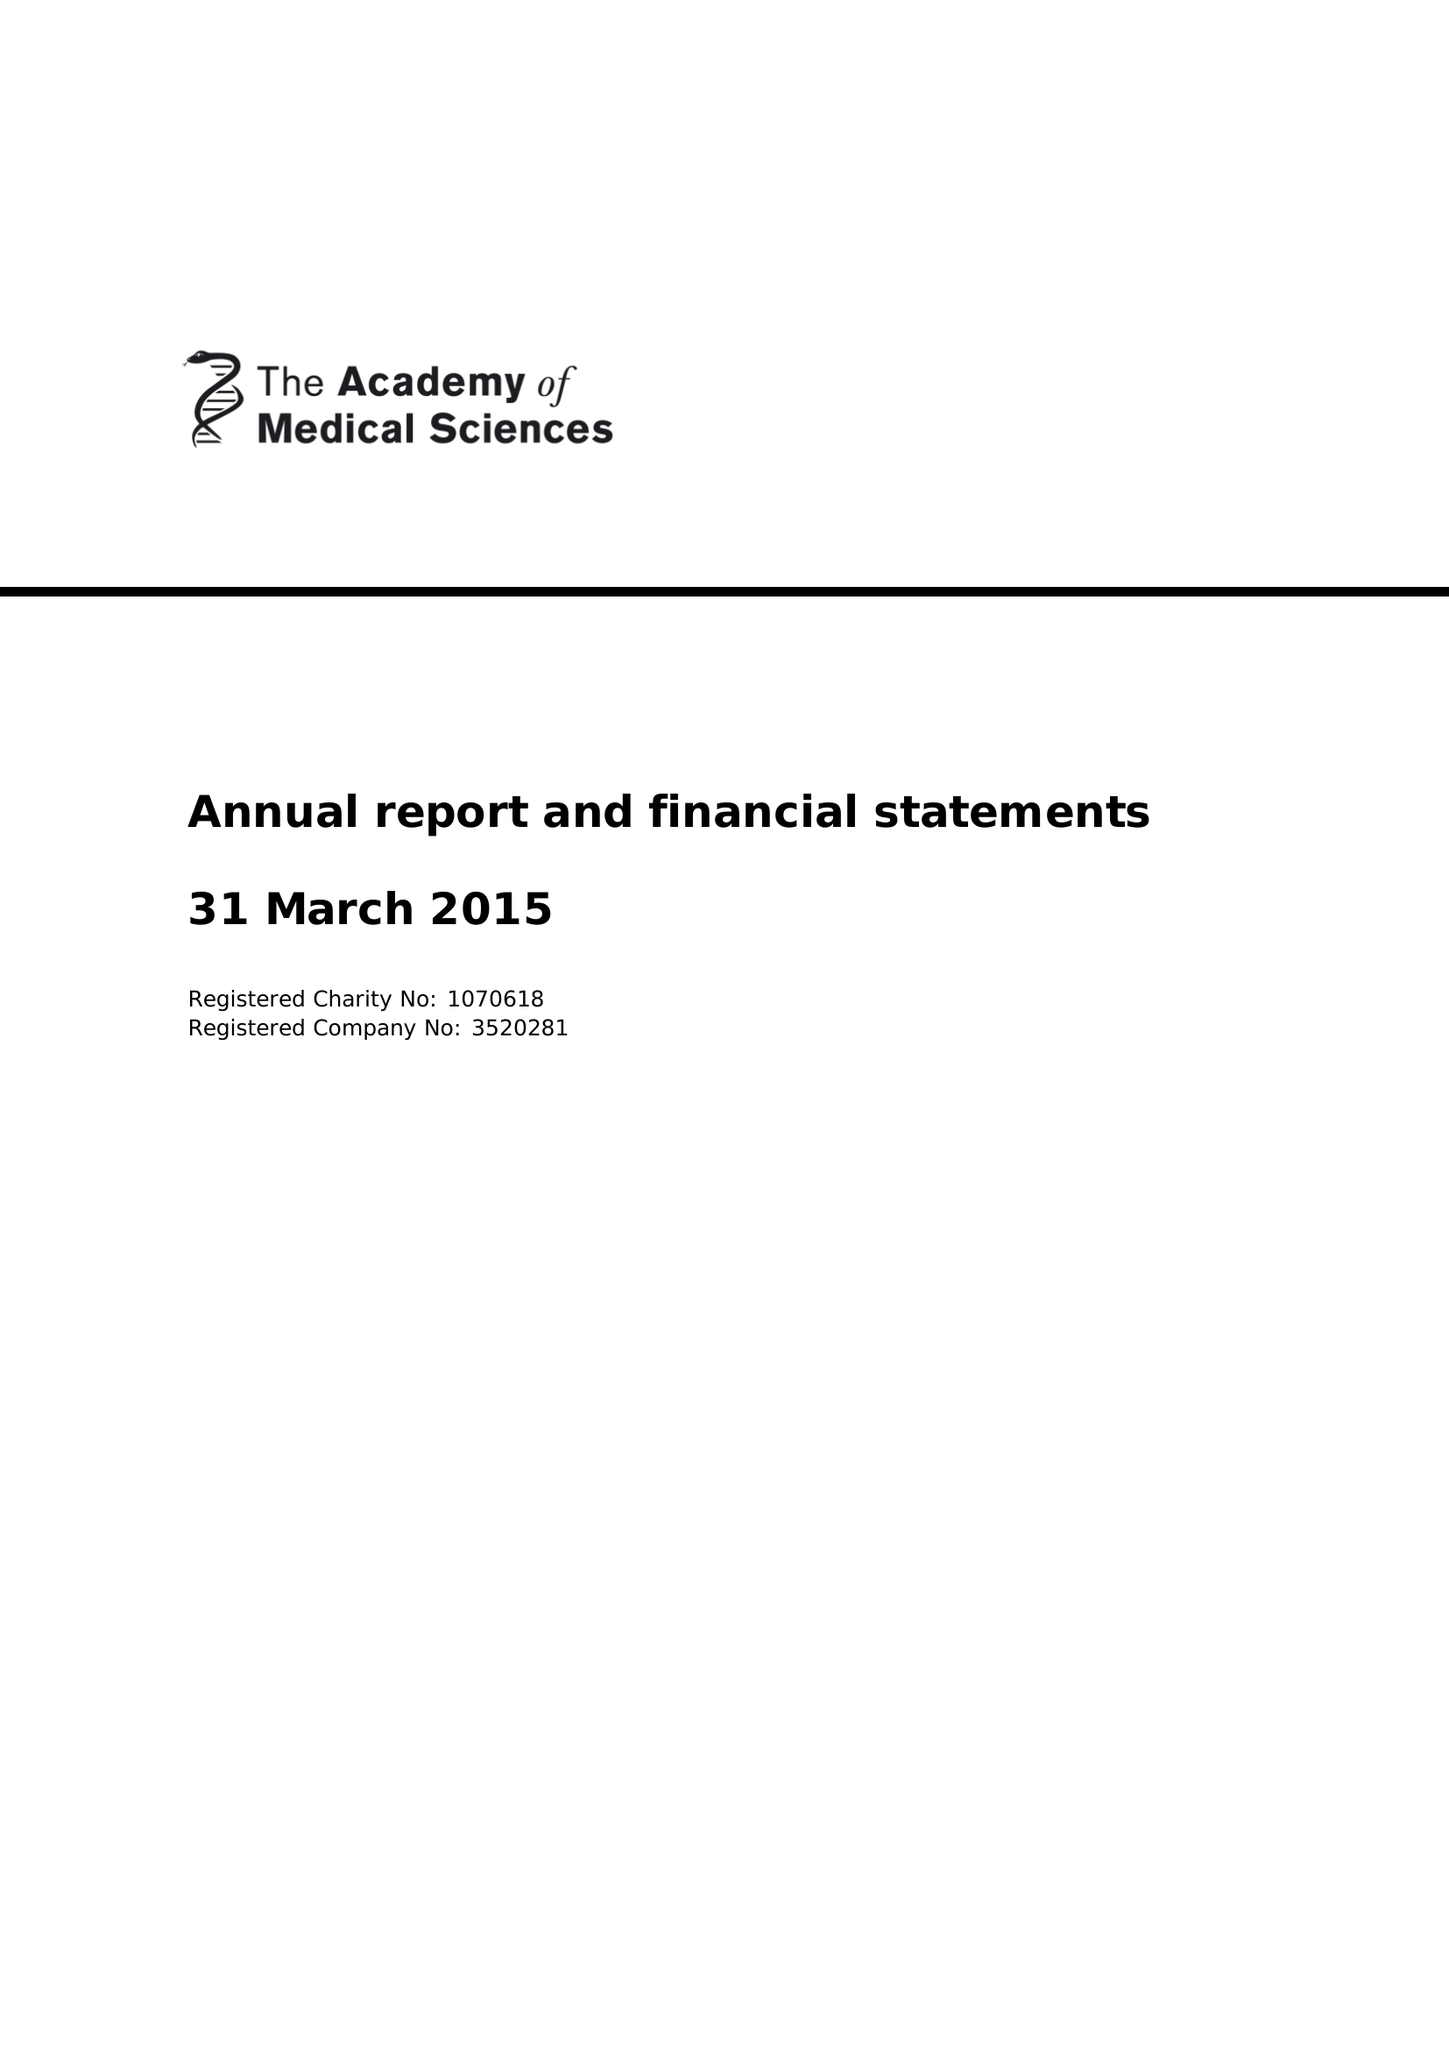What is the value for the income_annually_in_british_pounds?
Answer the question using a single word or phrase. 5799261.00 